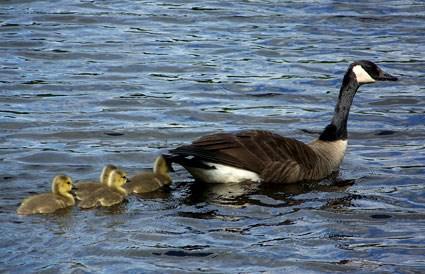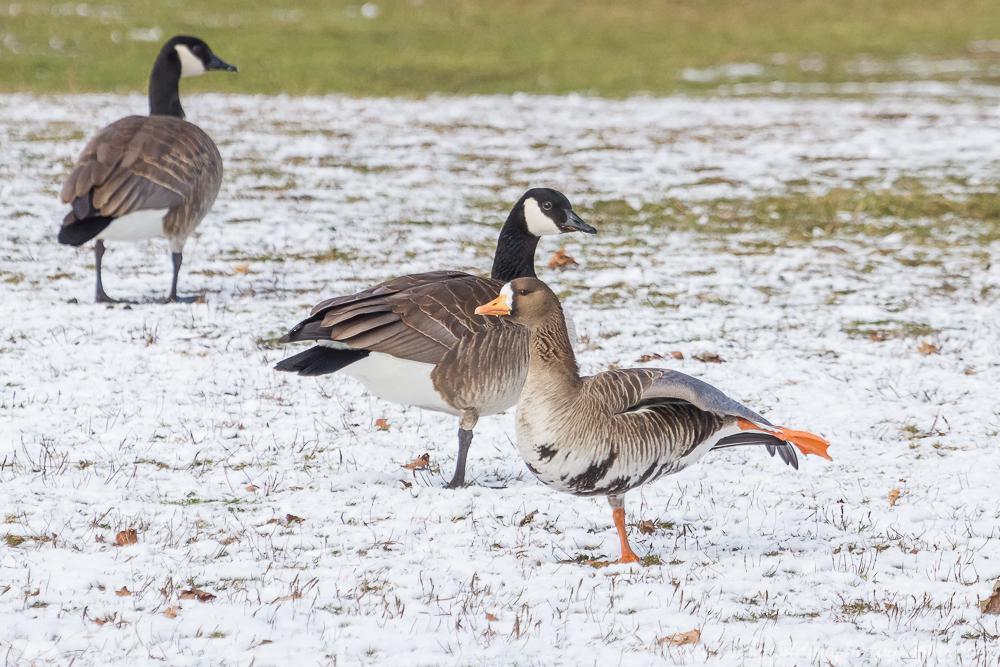The first image is the image on the left, the second image is the image on the right. Evaluate the accuracy of this statement regarding the images: "An image shows at least one baby gosling next to an adult goose.". Is it true? Answer yes or no. Yes. The first image is the image on the left, the second image is the image on the right. Given the left and right images, does the statement "One image shows an adult Canada goose and at least one gosling, while the other image shows all adult Canada geese." hold true? Answer yes or no. Yes. 